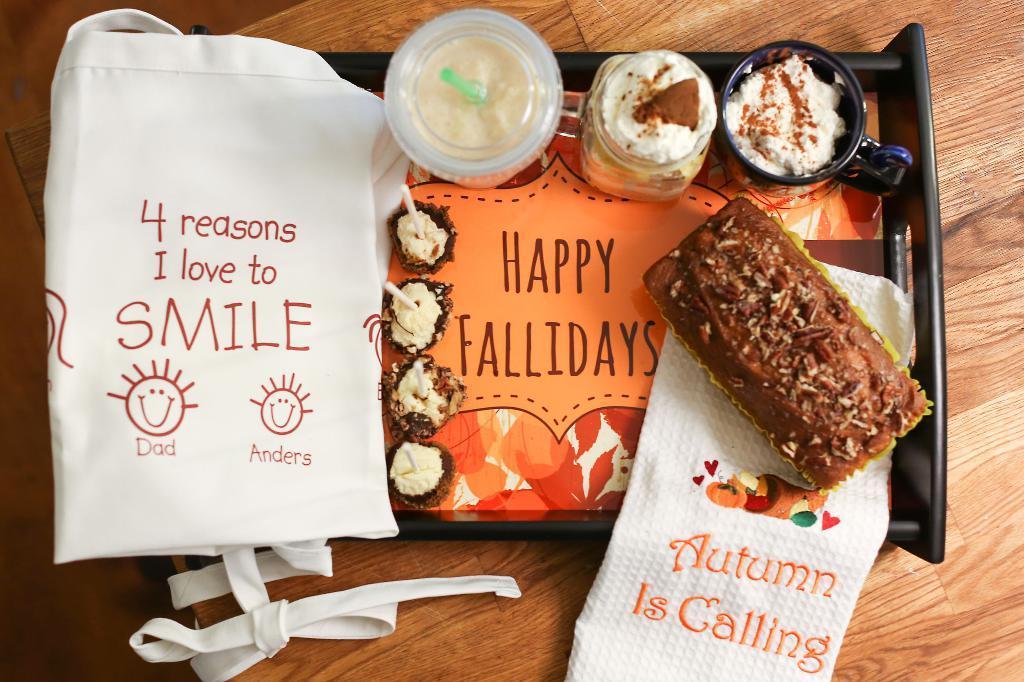Please provide a concise description of this image. In this picture there are cup cakes and there are cups and there is a cake and there are clothes in the tray and there is text on the clothes and there is text on tray. At the bottom there is a table. 